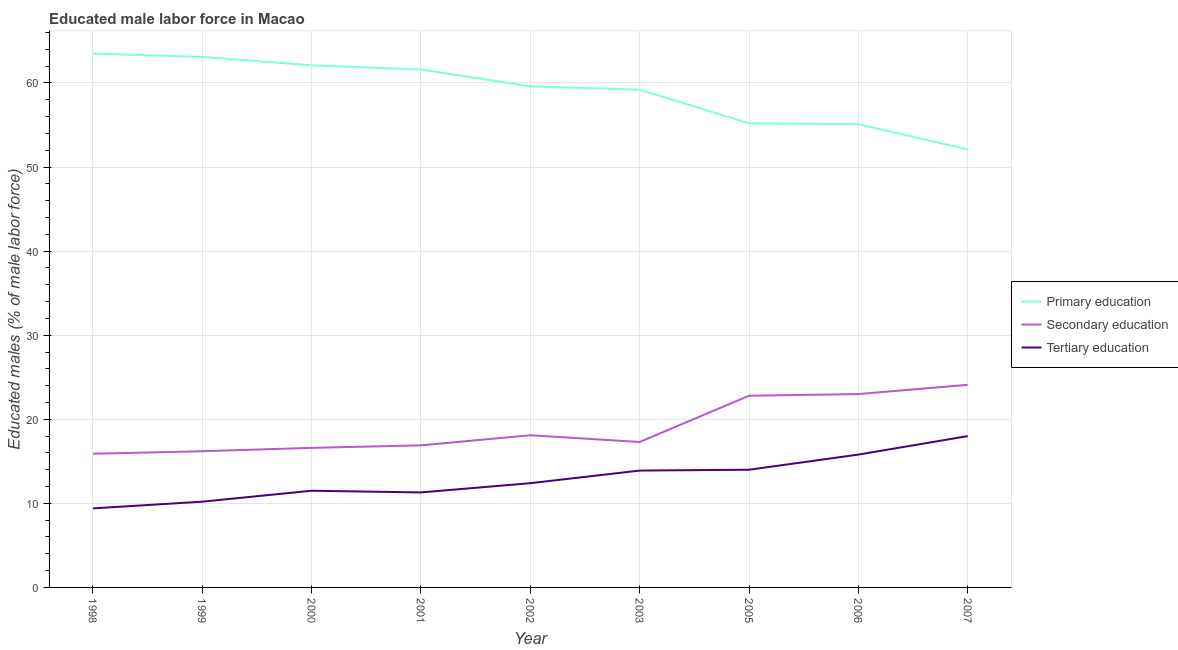How many different coloured lines are there?
Provide a short and direct response. 3. Does the line corresponding to percentage of male labor force who received tertiary education intersect with the line corresponding to percentage of male labor force who received primary education?
Your answer should be very brief. No. Is the number of lines equal to the number of legend labels?
Provide a short and direct response. Yes. What is the percentage of male labor force who received primary education in 2007?
Your response must be concise. 52.1. Across all years, what is the minimum percentage of male labor force who received secondary education?
Give a very brief answer. 15.9. In which year was the percentage of male labor force who received primary education maximum?
Keep it short and to the point. 1998. In which year was the percentage of male labor force who received tertiary education minimum?
Make the answer very short. 1998. What is the total percentage of male labor force who received tertiary education in the graph?
Make the answer very short. 116.5. What is the difference between the percentage of male labor force who received secondary education in 2003 and that in 2007?
Keep it short and to the point. -6.8. What is the difference between the percentage of male labor force who received tertiary education in 2006 and the percentage of male labor force who received primary education in 2003?
Your answer should be very brief. -43.4. What is the average percentage of male labor force who received secondary education per year?
Your response must be concise. 18.99. In the year 2003, what is the difference between the percentage of male labor force who received secondary education and percentage of male labor force who received tertiary education?
Provide a succinct answer. 3.4. In how many years, is the percentage of male labor force who received primary education greater than 16 %?
Offer a very short reply. 9. What is the ratio of the percentage of male labor force who received primary education in 1998 to that in 2002?
Make the answer very short. 1.07. Is the percentage of male labor force who received secondary education in 1998 less than that in 2000?
Keep it short and to the point. Yes. What is the difference between the highest and the second highest percentage of male labor force who received secondary education?
Provide a short and direct response. 1.1. What is the difference between the highest and the lowest percentage of male labor force who received primary education?
Provide a succinct answer. 11.4. Is the sum of the percentage of male labor force who received primary education in 1998 and 2000 greater than the maximum percentage of male labor force who received secondary education across all years?
Your response must be concise. Yes. Is it the case that in every year, the sum of the percentage of male labor force who received primary education and percentage of male labor force who received secondary education is greater than the percentage of male labor force who received tertiary education?
Make the answer very short. Yes. Does the percentage of male labor force who received tertiary education monotonically increase over the years?
Your response must be concise. No. How are the legend labels stacked?
Give a very brief answer. Vertical. What is the title of the graph?
Make the answer very short. Educated male labor force in Macao. What is the label or title of the Y-axis?
Make the answer very short. Educated males (% of male labor force). What is the Educated males (% of male labor force) of Primary education in 1998?
Offer a very short reply. 63.5. What is the Educated males (% of male labor force) in Secondary education in 1998?
Make the answer very short. 15.9. What is the Educated males (% of male labor force) in Tertiary education in 1998?
Provide a short and direct response. 9.4. What is the Educated males (% of male labor force) of Primary education in 1999?
Your answer should be very brief. 63.1. What is the Educated males (% of male labor force) in Secondary education in 1999?
Your answer should be very brief. 16.2. What is the Educated males (% of male labor force) of Tertiary education in 1999?
Ensure brevity in your answer.  10.2. What is the Educated males (% of male labor force) in Primary education in 2000?
Your answer should be very brief. 62.1. What is the Educated males (% of male labor force) in Secondary education in 2000?
Offer a very short reply. 16.6. What is the Educated males (% of male labor force) in Primary education in 2001?
Your response must be concise. 61.6. What is the Educated males (% of male labor force) of Secondary education in 2001?
Your answer should be very brief. 16.9. What is the Educated males (% of male labor force) in Tertiary education in 2001?
Keep it short and to the point. 11.3. What is the Educated males (% of male labor force) of Primary education in 2002?
Offer a very short reply. 59.6. What is the Educated males (% of male labor force) in Secondary education in 2002?
Ensure brevity in your answer.  18.1. What is the Educated males (% of male labor force) in Tertiary education in 2002?
Your answer should be very brief. 12.4. What is the Educated males (% of male labor force) in Primary education in 2003?
Your response must be concise. 59.2. What is the Educated males (% of male labor force) in Secondary education in 2003?
Your answer should be compact. 17.3. What is the Educated males (% of male labor force) of Tertiary education in 2003?
Make the answer very short. 13.9. What is the Educated males (% of male labor force) of Primary education in 2005?
Offer a very short reply. 55.2. What is the Educated males (% of male labor force) of Secondary education in 2005?
Give a very brief answer. 22.8. What is the Educated males (% of male labor force) of Primary education in 2006?
Provide a short and direct response. 55.1. What is the Educated males (% of male labor force) of Tertiary education in 2006?
Ensure brevity in your answer.  15.8. What is the Educated males (% of male labor force) of Primary education in 2007?
Your answer should be compact. 52.1. What is the Educated males (% of male labor force) of Secondary education in 2007?
Your response must be concise. 24.1. Across all years, what is the maximum Educated males (% of male labor force) in Primary education?
Offer a very short reply. 63.5. Across all years, what is the maximum Educated males (% of male labor force) of Secondary education?
Make the answer very short. 24.1. Across all years, what is the minimum Educated males (% of male labor force) of Primary education?
Offer a very short reply. 52.1. Across all years, what is the minimum Educated males (% of male labor force) of Secondary education?
Your response must be concise. 15.9. Across all years, what is the minimum Educated males (% of male labor force) of Tertiary education?
Your answer should be compact. 9.4. What is the total Educated males (% of male labor force) of Primary education in the graph?
Offer a terse response. 531.5. What is the total Educated males (% of male labor force) in Secondary education in the graph?
Offer a terse response. 170.9. What is the total Educated males (% of male labor force) in Tertiary education in the graph?
Make the answer very short. 116.5. What is the difference between the Educated males (% of male labor force) in Primary education in 1998 and that in 1999?
Offer a very short reply. 0.4. What is the difference between the Educated males (% of male labor force) of Tertiary education in 1998 and that in 1999?
Ensure brevity in your answer.  -0.8. What is the difference between the Educated males (% of male labor force) of Primary education in 1998 and that in 2001?
Make the answer very short. 1.9. What is the difference between the Educated males (% of male labor force) in Secondary education in 1998 and that in 2001?
Your answer should be very brief. -1. What is the difference between the Educated males (% of male labor force) in Tertiary education in 1998 and that in 2001?
Make the answer very short. -1.9. What is the difference between the Educated males (% of male labor force) in Tertiary education in 1998 and that in 2002?
Provide a succinct answer. -3. What is the difference between the Educated males (% of male labor force) in Primary education in 1998 and that in 2003?
Give a very brief answer. 4.3. What is the difference between the Educated males (% of male labor force) in Secondary education in 1998 and that in 2005?
Your response must be concise. -6.9. What is the difference between the Educated males (% of male labor force) in Tertiary education in 1998 and that in 2005?
Your answer should be very brief. -4.6. What is the difference between the Educated males (% of male labor force) in Tertiary education in 1998 and that in 2006?
Your answer should be very brief. -6.4. What is the difference between the Educated males (% of male labor force) of Secondary education in 1998 and that in 2007?
Keep it short and to the point. -8.2. What is the difference between the Educated males (% of male labor force) in Secondary education in 1999 and that in 2001?
Provide a succinct answer. -0.7. What is the difference between the Educated males (% of male labor force) in Tertiary education in 1999 and that in 2001?
Ensure brevity in your answer.  -1.1. What is the difference between the Educated males (% of male labor force) of Primary education in 1999 and that in 2003?
Your answer should be compact. 3.9. What is the difference between the Educated males (% of male labor force) of Secondary education in 1999 and that in 2003?
Provide a short and direct response. -1.1. What is the difference between the Educated males (% of male labor force) of Primary education in 1999 and that in 2006?
Your response must be concise. 8. What is the difference between the Educated males (% of male labor force) in Secondary education in 1999 and that in 2006?
Your answer should be compact. -6.8. What is the difference between the Educated males (% of male labor force) of Secondary education in 1999 and that in 2007?
Your response must be concise. -7.9. What is the difference between the Educated males (% of male labor force) in Primary education in 2000 and that in 2001?
Give a very brief answer. 0.5. What is the difference between the Educated males (% of male labor force) of Secondary education in 2000 and that in 2001?
Give a very brief answer. -0.3. What is the difference between the Educated males (% of male labor force) in Tertiary education in 2000 and that in 2001?
Give a very brief answer. 0.2. What is the difference between the Educated males (% of male labor force) in Primary education in 2000 and that in 2002?
Give a very brief answer. 2.5. What is the difference between the Educated males (% of male labor force) of Primary education in 2000 and that in 2003?
Ensure brevity in your answer.  2.9. What is the difference between the Educated males (% of male labor force) in Secondary education in 2000 and that in 2003?
Your answer should be very brief. -0.7. What is the difference between the Educated males (% of male labor force) of Secondary education in 2000 and that in 2005?
Keep it short and to the point. -6.2. What is the difference between the Educated males (% of male labor force) in Secondary education in 2000 and that in 2006?
Give a very brief answer. -6.4. What is the difference between the Educated males (% of male labor force) in Tertiary education in 2000 and that in 2006?
Your answer should be very brief. -4.3. What is the difference between the Educated males (% of male labor force) of Primary education in 2000 and that in 2007?
Offer a terse response. 10. What is the difference between the Educated males (% of male labor force) of Tertiary education in 2000 and that in 2007?
Your response must be concise. -6.5. What is the difference between the Educated males (% of male labor force) of Primary education in 2001 and that in 2002?
Keep it short and to the point. 2. What is the difference between the Educated males (% of male labor force) of Primary education in 2001 and that in 2003?
Your answer should be very brief. 2.4. What is the difference between the Educated males (% of male labor force) in Tertiary education in 2001 and that in 2003?
Ensure brevity in your answer.  -2.6. What is the difference between the Educated males (% of male labor force) of Primary education in 2001 and that in 2005?
Offer a very short reply. 6.4. What is the difference between the Educated males (% of male labor force) of Tertiary education in 2001 and that in 2005?
Provide a succinct answer. -2.7. What is the difference between the Educated males (% of male labor force) of Primary education in 2001 and that in 2006?
Your answer should be compact. 6.5. What is the difference between the Educated males (% of male labor force) in Primary education in 2002 and that in 2003?
Offer a very short reply. 0.4. What is the difference between the Educated males (% of male labor force) of Secondary education in 2002 and that in 2003?
Your answer should be very brief. 0.8. What is the difference between the Educated males (% of male labor force) in Primary education in 2003 and that in 2005?
Your answer should be very brief. 4. What is the difference between the Educated males (% of male labor force) of Tertiary education in 2003 and that in 2005?
Ensure brevity in your answer.  -0.1. What is the difference between the Educated males (% of male labor force) of Primary education in 2003 and that in 2007?
Keep it short and to the point. 7.1. What is the difference between the Educated males (% of male labor force) in Tertiary education in 2003 and that in 2007?
Provide a succinct answer. -4.1. What is the difference between the Educated males (% of male labor force) of Primary education in 2005 and that in 2006?
Keep it short and to the point. 0.1. What is the difference between the Educated males (% of male labor force) in Secondary education in 2005 and that in 2007?
Provide a succinct answer. -1.3. What is the difference between the Educated males (% of male labor force) of Secondary education in 2006 and that in 2007?
Keep it short and to the point. -1.1. What is the difference between the Educated males (% of male labor force) of Tertiary education in 2006 and that in 2007?
Provide a succinct answer. -2.2. What is the difference between the Educated males (% of male labor force) of Primary education in 1998 and the Educated males (% of male labor force) of Secondary education in 1999?
Ensure brevity in your answer.  47.3. What is the difference between the Educated males (% of male labor force) in Primary education in 1998 and the Educated males (% of male labor force) in Tertiary education in 1999?
Ensure brevity in your answer.  53.3. What is the difference between the Educated males (% of male labor force) in Secondary education in 1998 and the Educated males (% of male labor force) in Tertiary education in 1999?
Your answer should be very brief. 5.7. What is the difference between the Educated males (% of male labor force) in Primary education in 1998 and the Educated males (% of male labor force) in Secondary education in 2000?
Offer a terse response. 46.9. What is the difference between the Educated males (% of male labor force) in Primary education in 1998 and the Educated males (% of male labor force) in Tertiary education in 2000?
Offer a terse response. 52. What is the difference between the Educated males (% of male labor force) in Primary education in 1998 and the Educated males (% of male labor force) in Secondary education in 2001?
Ensure brevity in your answer.  46.6. What is the difference between the Educated males (% of male labor force) of Primary education in 1998 and the Educated males (% of male labor force) of Tertiary education in 2001?
Ensure brevity in your answer.  52.2. What is the difference between the Educated males (% of male labor force) in Secondary education in 1998 and the Educated males (% of male labor force) in Tertiary education in 2001?
Keep it short and to the point. 4.6. What is the difference between the Educated males (% of male labor force) of Primary education in 1998 and the Educated males (% of male labor force) of Secondary education in 2002?
Your answer should be very brief. 45.4. What is the difference between the Educated males (% of male labor force) of Primary education in 1998 and the Educated males (% of male labor force) of Tertiary education in 2002?
Your answer should be compact. 51.1. What is the difference between the Educated males (% of male labor force) of Secondary education in 1998 and the Educated males (% of male labor force) of Tertiary education in 2002?
Give a very brief answer. 3.5. What is the difference between the Educated males (% of male labor force) of Primary education in 1998 and the Educated males (% of male labor force) of Secondary education in 2003?
Offer a terse response. 46.2. What is the difference between the Educated males (% of male labor force) in Primary education in 1998 and the Educated males (% of male labor force) in Tertiary education in 2003?
Provide a short and direct response. 49.6. What is the difference between the Educated males (% of male labor force) in Secondary education in 1998 and the Educated males (% of male labor force) in Tertiary education in 2003?
Your answer should be compact. 2. What is the difference between the Educated males (% of male labor force) in Primary education in 1998 and the Educated males (% of male labor force) in Secondary education in 2005?
Keep it short and to the point. 40.7. What is the difference between the Educated males (% of male labor force) in Primary education in 1998 and the Educated males (% of male labor force) in Tertiary education in 2005?
Provide a succinct answer. 49.5. What is the difference between the Educated males (% of male labor force) of Secondary education in 1998 and the Educated males (% of male labor force) of Tertiary education in 2005?
Offer a very short reply. 1.9. What is the difference between the Educated males (% of male labor force) of Primary education in 1998 and the Educated males (% of male labor force) of Secondary education in 2006?
Offer a very short reply. 40.5. What is the difference between the Educated males (% of male labor force) in Primary education in 1998 and the Educated males (% of male labor force) in Tertiary education in 2006?
Keep it short and to the point. 47.7. What is the difference between the Educated males (% of male labor force) in Secondary education in 1998 and the Educated males (% of male labor force) in Tertiary education in 2006?
Your answer should be very brief. 0.1. What is the difference between the Educated males (% of male labor force) in Primary education in 1998 and the Educated males (% of male labor force) in Secondary education in 2007?
Provide a succinct answer. 39.4. What is the difference between the Educated males (% of male labor force) of Primary education in 1998 and the Educated males (% of male labor force) of Tertiary education in 2007?
Your answer should be compact. 45.5. What is the difference between the Educated males (% of male labor force) of Primary education in 1999 and the Educated males (% of male labor force) of Secondary education in 2000?
Keep it short and to the point. 46.5. What is the difference between the Educated males (% of male labor force) in Primary education in 1999 and the Educated males (% of male labor force) in Tertiary education in 2000?
Your answer should be compact. 51.6. What is the difference between the Educated males (% of male labor force) in Primary education in 1999 and the Educated males (% of male labor force) in Secondary education in 2001?
Keep it short and to the point. 46.2. What is the difference between the Educated males (% of male labor force) in Primary education in 1999 and the Educated males (% of male labor force) in Tertiary education in 2001?
Your response must be concise. 51.8. What is the difference between the Educated males (% of male labor force) in Primary education in 1999 and the Educated males (% of male labor force) in Secondary education in 2002?
Ensure brevity in your answer.  45. What is the difference between the Educated males (% of male labor force) in Primary education in 1999 and the Educated males (% of male labor force) in Tertiary education in 2002?
Give a very brief answer. 50.7. What is the difference between the Educated males (% of male labor force) in Primary education in 1999 and the Educated males (% of male labor force) in Secondary education in 2003?
Provide a short and direct response. 45.8. What is the difference between the Educated males (% of male labor force) in Primary education in 1999 and the Educated males (% of male labor force) in Tertiary education in 2003?
Keep it short and to the point. 49.2. What is the difference between the Educated males (% of male labor force) of Primary education in 1999 and the Educated males (% of male labor force) of Secondary education in 2005?
Ensure brevity in your answer.  40.3. What is the difference between the Educated males (% of male labor force) in Primary education in 1999 and the Educated males (% of male labor force) in Tertiary education in 2005?
Make the answer very short. 49.1. What is the difference between the Educated males (% of male labor force) of Secondary education in 1999 and the Educated males (% of male labor force) of Tertiary education in 2005?
Give a very brief answer. 2.2. What is the difference between the Educated males (% of male labor force) in Primary education in 1999 and the Educated males (% of male labor force) in Secondary education in 2006?
Your answer should be very brief. 40.1. What is the difference between the Educated males (% of male labor force) in Primary education in 1999 and the Educated males (% of male labor force) in Tertiary education in 2006?
Your answer should be very brief. 47.3. What is the difference between the Educated males (% of male labor force) of Primary education in 1999 and the Educated males (% of male labor force) of Tertiary education in 2007?
Provide a short and direct response. 45.1. What is the difference between the Educated males (% of male labor force) of Primary education in 2000 and the Educated males (% of male labor force) of Secondary education in 2001?
Provide a succinct answer. 45.2. What is the difference between the Educated males (% of male labor force) of Primary education in 2000 and the Educated males (% of male labor force) of Tertiary education in 2001?
Keep it short and to the point. 50.8. What is the difference between the Educated males (% of male labor force) in Primary education in 2000 and the Educated males (% of male labor force) in Tertiary education in 2002?
Ensure brevity in your answer.  49.7. What is the difference between the Educated males (% of male labor force) in Primary education in 2000 and the Educated males (% of male labor force) in Secondary education in 2003?
Provide a succinct answer. 44.8. What is the difference between the Educated males (% of male labor force) in Primary education in 2000 and the Educated males (% of male labor force) in Tertiary education in 2003?
Ensure brevity in your answer.  48.2. What is the difference between the Educated males (% of male labor force) of Primary education in 2000 and the Educated males (% of male labor force) of Secondary education in 2005?
Ensure brevity in your answer.  39.3. What is the difference between the Educated males (% of male labor force) of Primary education in 2000 and the Educated males (% of male labor force) of Tertiary education in 2005?
Your response must be concise. 48.1. What is the difference between the Educated males (% of male labor force) in Secondary education in 2000 and the Educated males (% of male labor force) in Tertiary education in 2005?
Make the answer very short. 2.6. What is the difference between the Educated males (% of male labor force) of Primary education in 2000 and the Educated males (% of male labor force) of Secondary education in 2006?
Your answer should be very brief. 39.1. What is the difference between the Educated males (% of male labor force) in Primary education in 2000 and the Educated males (% of male labor force) in Tertiary education in 2006?
Your response must be concise. 46.3. What is the difference between the Educated males (% of male labor force) in Primary education in 2000 and the Educated males (% of male labor force) in Secondary education in 2007?
Ensure brevity in your answer.  38. What is the difference between the Educated males (% of male labor force) in Primary education in 2000 and the Educated males (% of male labor force) in Tertiary education in 2007?
Ensure brevity in your answer.  44.1. What is the difference between the Educated males (% of male labor force) in Primary education in 2001 and the Educated males (% of male labor force) in Secondary education in 2002?
Your answer should be compact. 43.5. What is the difference between the Educated males (% of male labor force) in Primary education in 2001 and the Educated males (% of male labor force) in Tertiary education in 2002?
Your response must be concise. 49.2. What is the difference between the Educated males (% of male labor force) of Secondary education in 2001 and the Educated males (% of male labor force) of Tertiary education in 2002?
Ensure brevity in your answer.  4.5. What is the difference between the Educated males (% of male labor force) of Primary education in 2001 and the Educated males (% of male labor force) of Secondary education in 2003?
Keep it short and to the point. 44.3. What is the difference between the Educated males (% of male labor force) in Primary education in 2001 and the Educated males (% of male labor force) in Tertiary education in 2003?
Make the answer very short. 47.7. What is the difference between the Educated males (% of male labor force) in Secondary education in 2001 and the Educated males (% of male labor force) in Tertiary education in 2003?
Give a very brief answer. 3. What is the difference between the Educated males (% of male labor force) of Primary education in 2001 and the Educated males (% of male labor force) of Secondary education in 2005?
Provide a short and direct response. 38.8. What is the difference between the Educated males (% of male labor force) of Primary education in 2001 and the Educated males (% of male labor force) of Tertiary education in 2005?
Your answer should be compact. 47.6. What is the difference between the Educated males (% of male labor force) in Secondary education in 2001 and the Educated males (% of male labor force) in Tertiary education in 2005?
Make the answer very short. 2.9. What is the difference between the Educated males (% of male labor force) in Primary education in 2001 and the Educated males (% of male labor force) in Secondary education in 2006?
Your answer should be very brief. 38.6. What is the difference between the Educated males (% of male labor force) in Primary education in 2001 and the Educated males (% of male labor force) in Tertiary education in 2006?
Your answer should be very brief. 45.8. What is the difference between the Educated males (% of male labor force) of Primary education in 2001 and the Educated males (% of male labor force) of Secondary education in 2007?
Your answer should be compact. 37.5. What is the difference between the Educated males (% of male labor force) of Primary education in 2001 and the Educated males (% of male labor force) of Tertiary education in 2007?
Provide a succinct answer. 43.6. What is the difference between the Educated males (% of male labor force) in Secondary education in 2001 and the Educated males (% of male labor force) in Tertiary education in 2007?
Make the answer very short. -1.1. What is the difference between the Educated males (% of male labor force) of Primary education in 2002 and the Educated males (% of male labor force) of Secondary education in 2003?
Offer a very short reply. 42.3. What is the difference between the Educated males (% of male labor force) in Primary education in 2002 and the Educated males (% of male labor force) in Tertiary education in 2003?
Give a very brief answer. 45.7. What is the difference between the Educated males (% of male labor force) of Secondary education in 2002 and the Educated males (% of male labor force) of Tertiary education in 2003?
Your answer should be compact. 4.2. What is the difference between the Educated males (% of male labor force) in Primary education in 2002 and the Educated males (% of male labor force) in Secondary education in 2005?
Your answer should be compact. 36.8. What is the difference between the Educated males (% of male labor force) in Primary education in 2002 and the Educated males (% of male labor force) in Tertiary education in 2005?
Make the answer very short. 45.6. What is the difference between the Educated males (% of male labor force) of Primary education in 2002 and the Educated males (% of male labor force) of Secondary education in 2006?
Provide a succinct answer. 36.6. What is the difference between the Educated males (% of male labor force) of Primary education in 2002 and the Educated males (% of male labor force) of Tertiary education in 2006?
Give a very brief answer. 43.8. What is the difference between the Educated males (% of male labor force) in Secondary education in 2002 and the Educated males (% of male labor force) in Tertiary education in 2006?
Your answer should be compact. 2.3. What is the difference between the Educated males (% of male labor force) in Primary education in 2002 and the Educated males (% of male labor force) in Secondary education in 2007?
Your answer should be very brief. 35.5. What is the difference between the Educated males (% of male labor force) in Primary education in 2002 and the Educated males (% of male labor force) in Tertiary education in 2007?
Make the answer very short. 41.6. What is the difference between the Educated males (% of male labor force) of Secondary education in 2002 and the Educated males (% of male labor force) of Tertiary education in 2007?
Your response must be concise. 0.1. What is the difference between the Educated males (% of male labor force) in Primary education in 2003 and the Educated males (% of male labor force) in Secondary education in 2005?
Your answer should be very brief. 36.4. What is the difference between the Educated males (% of male labor force) in Primary education in 2003 and the Educated males (% of male labor force) in Tertiary education in 2005?
Ensure brevity in your answer.  45.2. What is the difference between the Educated males (% of male labor force) of Primary education in 2003 and the Educated males (% of male labor force) of Secondary education in 2006?
Offer a very short reply. 36.2. What is the difference between the Educated males (% of male labor force) of Primary education in 2003 and the Educated males (% of male labor force) of Tertiary education in 2006?
Provide a short and direct response. 43.4. What is the difference between the Educated males (% of male labor force) in Primary education in 2003 and the Educated males (% of male labor force) in Secondary education in 2007?
Your response must be concise. 35.1. What is the difference between the Educated males (% of male labor force) in Primary education in 2003 and the Educated males (% of male labor force) in Tertiary education in 2007?
Your response must be concise. 41.2. What is the difference between the Educated males (% of male labor force) of Primary education in 2005 and the Educated males (% of male labor force) of Secondary education in 2006?
Keep it short and to the point. 32.2. What is the difference between the Educated males (% of male labor force) of Primary education in 2005 and the Educated males (% of male labor force) of Tertiary education in 2006?
Provide a succinct answer. 39.4. What is the difference between the Educated males (% of male labor force) of Primary education in 2005 and the Educated males (% of male labor force) of Secondary education in 2007?
Give a very brief answer. 31.1. What is the difference between the Educated males (% of male labor force) in Primary education in 2005 and the Educated males (% of male labor force) in Tertiary education in 2007?
Offer a terse response. 37.2. What is the difference between the Educated males (% of male labor force) of Secondary education in 2005 and the Educated males (% of male labor force) of Tertiary education in 2007?
Provide a succinct answer. 4.8. What is the difference between the Educated males (% of male labor force) of Primary education in 2006 and the Educated males (% of male labor force) of Secondary education in 2007?
Keep it short and to the point. 31. What is the difference between the Educated males (% of male labor force) of Primary education in 2006 and the Educated males (% of male labor force) of Tertiary education in 2007?
Your answer should be very brief. 37.1. What is the average Educated males (% of male labor force) of Primary education per year?
Give a very brief answer. 59.06. What is the average Educated males (% of male labor force) in Secondary education per year?
Your answer should be compact. 18.99. What is the average Educated males (% of male labor force) of Tertiary education per year?
Offer a terse response. 12.94. In the year 1998, what is the difference between the Educated males (% of male labor force) of Primary education and Educated males (% of male labor force) of Secondary education?
Offer a terse response. 47.6. In the year 1998, what is the difference between the Educated males (% of male labor force) in Primary education and Educated males (% of male labor force) in Tertiary education?
Your response must be concise. 54.1. In the year 1999, what is the difference between the Educated males (% of male labor force) in Primary education and Educated males (% of male labor force) in Secondary education?
Your response must be concise. 46.9. In the year 1999, what is the difference between the Educated males (% of male labor force) in Primary education and Educated males (% of male labor force) in Tertiary education?
Your answer should be compact. 52.9. In the year 2000, what is the difference between the Educated males (% of male labor force) in Primary education and Educated males (% of male labor force) in Secondary education?
Give a very brief answer. 45.5. In the year 2000, what is the difference between the Educated males (% of male labor force) of Primary education and Educated males (% of male labor force) of Tertiary education?
Ensure brevity in your answer.  50.6. In the year 2001, what is the difference between the Educated males (% of male labor force) in Primary education and Educated males (% of male labor force) in Secondary education?
Ensure brevity in your answer.  44.7. In the year 2001, what is the difference between the Educated males (% of male labor force) in Primary education and Educated males (% of male labor force) in Tertiary education?
Make the answer very short. 50.3. In the year 2002, what is the difference between the Educated males (% of male labor force) in Primary education and Educated males (% of male labor force) in Secondary education?
Your answer should be very brief. 41.5. In the year 2002, what is the difference between the Educated males (% of male labor force) in Primary education and Educated males (% of male labor force) in Tertiary education?
Your response must be concise. 47.2. In the year 2003, what is the difference between the Educated males (% of male labor force) in Primary education and Educated males (% of male labor force) in Secondary education?
Offer a very short reply. 41.9. In the year 2003, what is the difference between the Educated males (% of male labor force) of Primary education and Educated males (% of male labor force) of Tertiary education?
Offer a terse response. 45.3. In the year 2005, what is the difference between the Educated males (% of male labor force) in Primary education and Educated males (% of male labor force) in Secondary education?
Offer a terse response. 32.4. In the year 2005, what is the difference between the Educated males (% of male labor force) of Primary education and Educated males (% of male labor force) of Tertiary education?
Offer a very short reply. 41.2. In the year 2006, what is the difference between the Educated males (% of male labor force) in Primary education and Educated males (% of male labor force) in Secondary education?
Provide a succinct answer. 32.1. In the year 2006, what is the difference between the Educated males (% of male labor force) of Primary education and Educated males (% of male labor force) of Tertiary education?
Give a very brief answer. 39.3. In the year 2007, what is the difference between the Educated males (% of male labor force) of Primary education and Educated males (% of male labor force) of Tertiary education?
Offer a very short reply. 34.1. In the year 2007, what is the difference between the Educated males (% of male labor force) in Secondary education and Educated males (% of male labor force) in Tertiary education?
Make the answer very short. 6.1. What is the ratio of the Educated males (% of male labor force) in Primary education in 1998 to that in 1999?
Your answer should be compact. 1.01. What is the ratio of the Educated males (% of male labor force) of Secondary education in 1998 to that in 1999?
Provide a short and direct response. 0.98. What is the ratio of the Educated males (% of male labor force) in Tertiary education in 1998 to that in 1999?
Your answer should be very brief. 0.92. What is the ratio of the Educated males (% of male labor force) of Primary education in 1998 to that in 2000?
Your answer should be very brief. 1.02. What is the ratio of the Educated males (% of male labor force) of Secondary education in 1998 to that in 2000?
Ensure brevity in your answer.  0.96. What is the ratio of the Educated males (% of male labor force) of Tertiary education in 1998 to that in 2000?
Give a very brief answer. 0.82. What is the ratio of the Educated males (% of male labor force) of Primary education in 1998 to that in 2001?
Your answer should be compact. 1.03. What is the ratio of the Educated males (% of male labor force) in Secondary education in 1998 to that in 2001?
Give a very brief answer. 0.94. What is the ratio of the Educated males (% of male labor force) of Tertiary education in 1998 to that in 2001?
Provide a succinct answer. 0.83. What is the ratio of the Educated males (% of male labor force) in Primary education in 1998 to that in 2002?
Make the answer very short. 1.07. What is the ratio of the Educated males (% of male labor force) of Secondary education in 1998 to that in 2002?
Your answer should be very brief. 0.88. What is the ratio of the Educated males (% of male labor force) of Tertiary education in 1998 to that in 2002?
Ensure brevity in your answer.  0.76. What is the ratio of the Educated males (% of male labor force) of Primary education in 1998 to that in 2003?
Your answer should be compact. 1.07. What is the ratio of the Educated males (% of male labor force) of Secondary education in 1998 to that in 2003?
Your response must be concise. 0.92. What is the ratio of the Educated males (% of male labor force) in Tertiary education in 1998 to that in 2003?
Your response must be concise. 0.68. What is the ratio of the Educated males (% of male labor force) in Primary education in 1998 to that in 2005?
Make the answer very short. 1.15. What is the ratio of the Educated males (% of male labor force) in Secondary education in 1998 to that in 2005?
Provide a succinct answer. 0.7. What is the ratio of the Educated males (% of male labor force) of Tertiary education in 1998 to that in 2005?
Your response must be concise. 0.67. What is the ratio of the Educated males (% of male labor force) in Primary education in 1998 to that in 2006?
Your response must be concise. 1.15. What is the ratio of the Educated males (% of male labor force) in Secondary education in 1998 to that in 2006?
Provide a succinct answer. 0.69. What is the ratio of the Educated males (% of male labor force) of Tertiary education in 1998 to that in 2006?
Provide a short and direct response. 0.59. What is the ratio of the Educated males (% of male labor force) in Primary education in 1998 to that in 2007?
Your answer should be very brief. 1.22. What is the ratio of the Educated males (% of male labor force) of Secondary education in 1998 to that in 2007?
Your response must be concise. 0.66. What is the ratio of the Educated males (% of male labor force) in Tertiary education in 1998 to that in 2007?
Your answer should be compact. 0.52. What is the ratio of the Educated males (% of male labor force) in Primary education in 1999 to that in 2000?
Offer a very short reply. 1.02. What is the ratio of the Educated males (% of male labor force) in Secondary education in 1999 to that in 2000?
Make the answer very short. 0.98. What is the ratio of the Educated males (% of male labor force) of Tertiary education in 1999 to that in 2000?
Your response must be concise. 0.89. What is the ratio of the Educated males (% of male labor force) in Primary education in 1999 to that in 2001?
Offer a very short reply. 1.02. What is the ratio of the Educated males (% of male labor force) of Secondary education in 1999 to that in 2001?
Provide a succinct answer. 0.96. What is the ratio of the Educated males (% of male labor force) in Tertiary education in 1999 to that in 2001?
Your answer should be very brief. 0.9. What is the ratio of the Educated males (% of male labor force) in Primary education in 1999 to that in 2002?
Offer a very short reply. 1.06. What is the ratio of the Educated males (% of male labor force) of Secondary education in 1999 to that in 2002?
Offer a very short reply. 0.9. What is the ratio of the Educated males (% of male labor force) in Tertiary education in 1999 to that in 2002?
Ensure brevity in your answer.  0.82. What is the ratio of the Educated males (% of male labor force) in Primary education in 1999 to that in 2003?
Ensure brevity in your answer.  1.07. What is the ratio of the Educated males (% of male labor force) in Secondary education in 1999 to that in 2003?
Ensure brevity in your answer.  0.94. What is the ratio of the Educated males (% of male labor force) of Tertiary education in 1999 to that in 2003?
Your answer should be very brief. 0.73. What is the ratio of the Educated males (% of male labor force) of Primary education in 1999 to that in 2005?
Keep it short and to the point. 1.14. What is the ratio of the Educated males (% of male labor force) in Secondary education in 1999 to that in 2005?
Keep it short and to the point. 0.71. What is the ratio of the Educated males (% of male labor force) of Tertiary education in 1999 to that in 2005?
Provide a succinct answer. 0.73. What is the ratio of the Educated males (% of male labor force) in Primary education in 1999 to that in 2006?
Your answer should be compact. 1.15. What is the ratio of the Educated males (% of male labor force) of Secondary education in 1999 to that in 2006?
Offer a very short reply. 0.7. What is the ratio of the Educated males (% of male labor force) in Tertiary education in 1999 to that in 2006?
Provide a succinct answer. 0.65. What is the ratio of the Educated males (% of male labor force) in Primary education in 1999 to that in 2007?
Give a very brief answer. 1.21. What is the ratio of the Educated males (% of male labor force) of Secondary education in 1999 to that in 2007?
Provide a succinct answer. 0.67. What is the ratio of the Educated males (% of male labor force) in Tertiary education in 1999 to that in 2007?
Provide a short and direct response. 0.57. What is the ratio of the Educated males (% of male labor force) of Primary education in 2000 to that in 2001?
Your answer should be compact. 1.01. What is the ratio of the Educated males (% of male labor force) in Secondary education in 2000 to that in 2001?
Keep it short and to the point. 0.98. What is the ratio of the Educated males (% of male labor force) of Tertiary education in 2000 to that in 2001?
Your answer should be compact. 1.02. What is the ratio of the Educated males (% of male labor force) in Primary education in 2000 to that in 2002?
Ensure brevity in your answer.  1.04. What is the ratio of the Educated males (% of male labor force) in Secondary education in 2000 to that in 2002?
Offer a very short reply. 0.92. What is the ratio of the Educated males (% of male labor force) of Tertiary education in 2000 to that in 2002?
Your response must be concise. 0.93. What is the ratio of the Educated males (% of male labor force) of Primary education in 2000 to that in 2003?
Keep it short and to the point. 1.05. What is the ratio of the Educated males (% of male labor force) in Secondary education in 2000 to that in 2003?
Give a very brief answer. 0.96. What is the ratio of the Educated males (% of male labor force) in Tertiary education in 2000 to that in 2003?
Your answer should be very brief. 0.83. What is the ratio of the Educated males (% of male labor force) in Secondary education in 2000 to that in 2005?
Your answer should be compact. 0.73. What is the ratio of the Educated males (% of male labor force) of Tertiary education in 2000 to that in 2005?
Provide a short and direct response. 0.82. What is the ratio of the Educated males (% of male labor force) of Primary education in 2000 to that in 2006?
Provide a short and direct response. 1.13. What is the ratio of the Educated males (% of male labor force) in Secondary education in 2000 to that in 2006?
Keep it short and to the point. 0.72. What is the ratio of the Educated males (% of male labor force) of Tertiary education in 2000 to that in 2006?
Offer a very short reply. 0.73. What is the ratio of the Educated males (% of male labor force) in Primary education in 2000 to that in 2007?
Offer a terse response. 1.19. What is the ratio of the Educated males (% of male labor force) of Secondary education in 2000 to that in 2007?
Your response must be concise. 0.69. What is the ratio of the Educated males (% of male labor force) of Tertiary education in 2000 to that in 2007?
Keep it short and to the point. 0.64. What is the ratio of the Educated males (% of male labor force) of Primary education in 2001 to that in 2002?
Ensure brevity in your answer.  1.03. What is the ratio of the Educated males (% of male labor force) in Secondary education in 2001 to that in 2002?
Provide a succinct answer. 0.93. What is the ratio of the Educated males (% of male labor force) in Tertiary education in 2001 to that in 2002?
Provide a short and direct response. 0.91. What is the ratio of the Educated males (% of male labor force) of Primary education in 2001 to that in 2003?
Your answer should be compact. 1.04. What is the ratio of the Educated males (% of male labor force) of Secondary education in 2001 to that in 2003?
Give a very brief answer. 0.98. What is the ratio of the Educated males (% of male labor force) of Tertiary education in 2001 to that in 2003?
Your answer should be very brief. 0.81. What is the ratio of the Educated males (% of male labor force) of Primary education in 2001 to that in 2005?
Provide a short and direct response. 1.12. What is the ratio of the Educated males (% of male labor force) of Secondary education in 2001 to that in 2005?
Ensure brevity in your answer.  0.74. What is the ratio of the Educated males (% of male labor force) of Tertiary education in 2001 to that in 2005?
Provide a succinct answer. 0.81. What is the ratio of the Educated males (% of male labor force) of Primary education in 2001 to that in 2006?
Offer a very short reply. 1.12. What is the ratio of the Educated males (% of male labor force) in Secondary education in 2001 to that in 2006?
Offer a terse response. 0.73. What is the ratio of the Educated males (% of male labor force) in Tertiary education in 2001 to that in 2006?
Give a very brief answer. 0.72. What is the ratio of the Educated males (% of male labor force) of Primary education in 2001 to that in 2007?
Your response must be concise. 1.18. What is the ratio of the Educated males (% of male labor force) in Secondary education in 2001 to that in 2007?
Your answer should be compact. 0.7. What is the ratio of the Educated males (% of male labor force) in Tertiary education in 2001 to that in 2007?
Your answer should be compact. 0.63. What is the ratio of the Educated males (% of male labor force) in Primary education in 2002 to that in 2003?
Your response must be concise. 1.01. What is the ratio of the Educated males (% of male labor force) of Secondary education in 2002 to that in 2003?
Make the answer very short. 1.05. What is the ratio of the Educated males (% of male labor force) in Tertiary education in 2002 to that in 2003?
Ensure brevity in your answer.  0.89. What is the ratio of the Educated males (% of male labor force) in Primary education in 2002 to that in 2005?
Your answer should be compact. 1.08. What is the ratio of the Educated males (% of male labor force) in Secondary education in 2002 to that in 2005?
Your answer should be very brief. 0.79. What is the ratio of the Educated males (% of male labor force) in Tertiary education in 2002 to that in 2005?
Give a very brief answer. 0.89. What is the ratio of the Educated males (% of male labor force) of Primary education in 2002 to that in 2006?
Keep it short and to the point. 1.08. What is the ratio of the Educated males (% of male labor force) of Secondary education in 2002 to that in 2006?
Keep it short and to the point. 0.79. What is the ratio of the Educated males (% of male labor force) in Tertiary education in 2002 to that in 2006?
Your answer should be compact. 0.78. What is the ratio of the Educated males (% of male labor force) of Primary education in 2002 to that in 2007?
Your answer should be very brief. 1.14. What is the ratio of the Educated males (% of male labor force) in Secondary education in 2002 to that in 2007?
Make the answer very short. 0.75. What is the ratio of the Educated males (% of male labor force) in Tertiary education in 2002 to that in 2007?
Your response must be concise. 0.69. What is the ratio of the Educated males (% of male labor force) in Primary education in 2003 to that in 2005?
Your response must be concise. 1.07. What is the ratio of the Educated males (% of male labor force) in Secondary education in 2003 to that in 2005?
Offer a very short reply. 0.76. What is the ratio of the Educated males (% of male labor force) of Tertiary education in 2003 to that in 2005?
Offer a terse response. 0.99. What is the ratio of the Educated males (% of male labor force) of Primary education in 2003 to that in 2006?
Keep it short and to the point. 1.07. What is the ratio of the Educated males (% of male labor force) in Secondary education in 2003 to that in 2006?
Your response must be concise. 0.75. What is the ratio of the Educated males (% of male labor force) of Tertiary education in 2003 to that in 2006?
Give a very brief answer. 0.88. What is the ratio of the Educated males (% of male labor force) of Primary education in 2003 to that in 2007?
Ensure brevity in your answer.  1.14. What is the ratio of the Educated males (% of male labor force) in Secondary education in 2003 to that in 2007?
Your answer should be very brief. 0.72. What is the ratio of the Educated males (% of male labor force) in Tertiary education in 2003 to that in 2007?
Your answer should be very brief. 0.77. What is the ratio of the Educated males (% of male labor force) in Tertiary education in 2005 to that in 2006?
Make the answer very short. 0.89. What is the ratio of the Educated males (% of male labor force) of Primary education in 2005 to that in 2007?
Offer a terse response. 1.06. What is the ratio of the Educated males (% of male labor force) of Secondary education in 2005 to that in 2007?
Provide a succinct answer. 0.95. What is the ratio of the Educated males (% of male labor force) of Tertiary education in 2005 to that in 2007?
Your response must be concise. 0.78. What is the ratio of the Educated males (% of male labor force) of Primary education in 2006 to that in 2007?
Your response must be concise. 1.06. What is the ratio of the Educated males (% of male labor force) of Secondary education in 2006 to that in 2007?
Offer a very short reply. 0.95. What is the ratio of the Educated males (% of male labor force) in Tertiary education in 2006 to that in 2007?
Your response must be concise. 0.88. What is the difference between the highest and the second highest Educated males (% of male labor force) of Primary education?
Provide a short and direct response. 0.4. What is the difference between the highest and the second highest Educated males (% of male labor force) of Secondary education?
Make the answer very short. 1.1. What is the difference between the highest and the second highest Educated males (% of male labor force) of Tertiary education?
Provide a succinct answer. 2.2. What is the difference between the highest and the lowest Educated males (% of male labor force) of Secondary education?
Provide a succinct answer. 8.2. What is the difference between the highest and the lowest Educated males (% of male labor force) of Tertiary education?
Keep it short and to the point. 8.6. 